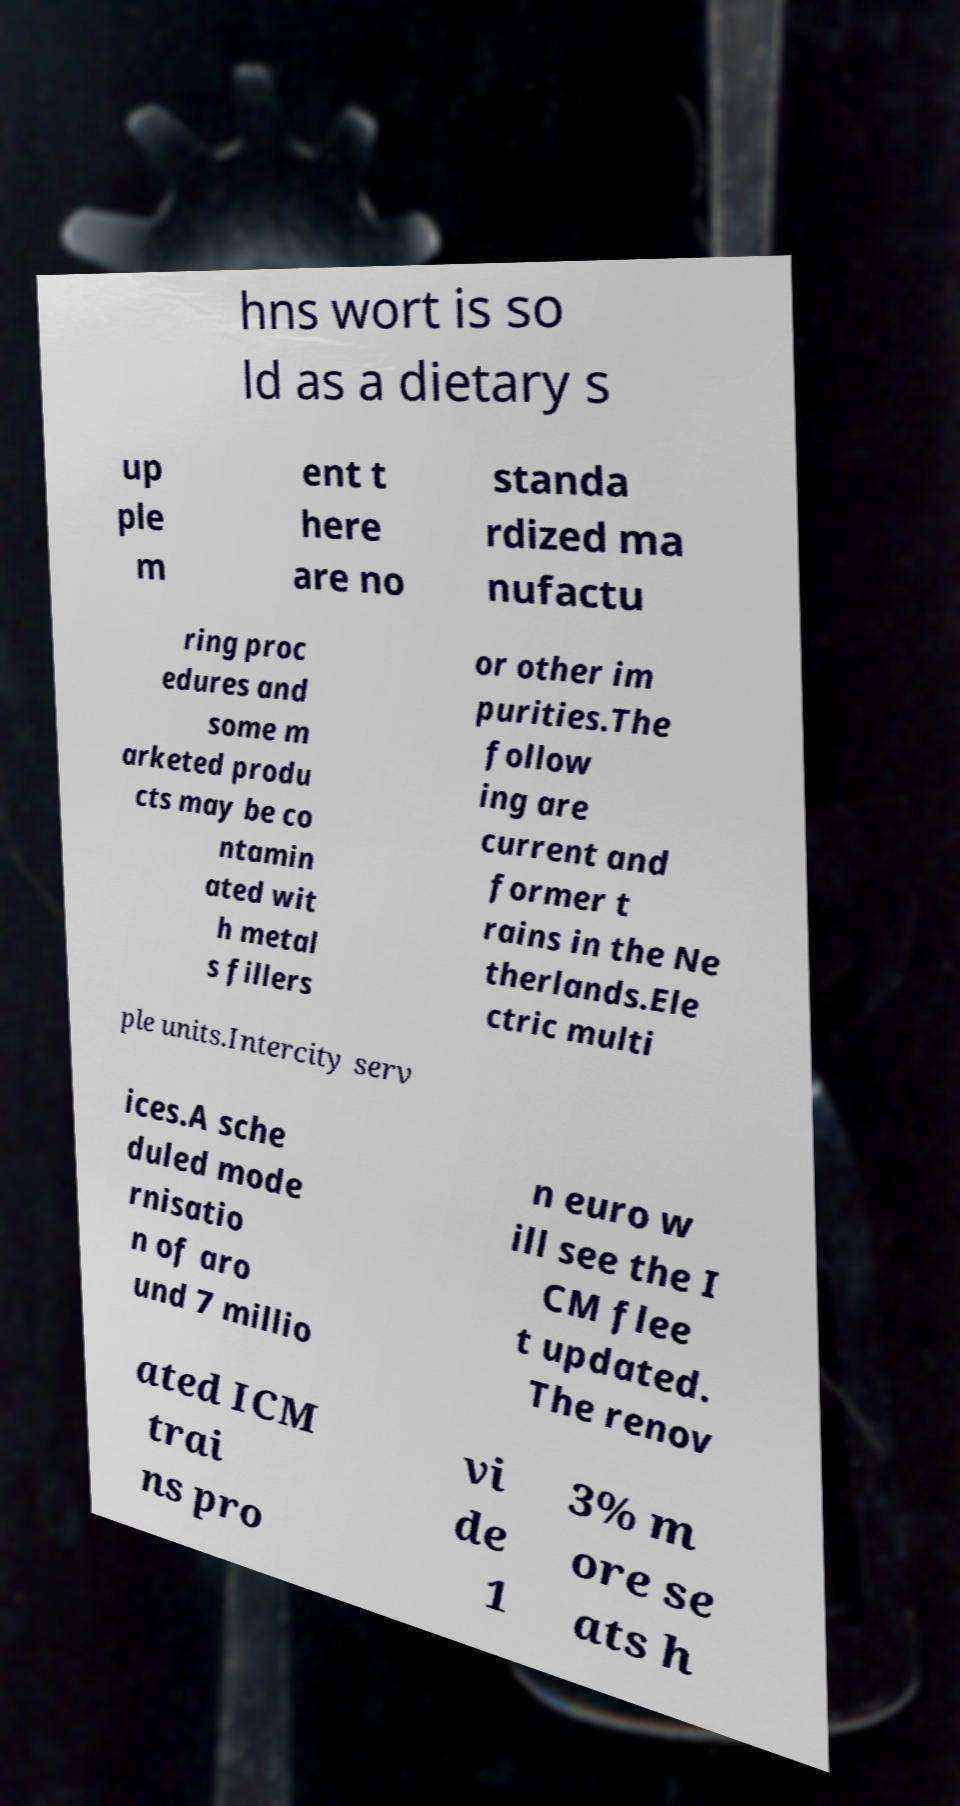There's text embedded in this image that I need extracted. Can you transcribe it verbatim? hns wort is so ld as a dietary s up ple m ent t here are no standa rdized ma nufactu ring proc edures and some m arketed produ cts may be co ntamin ated wit h metal s fillers or other im purities.The follow ing are current and former t rains in the Ne therlands.Ele ctric multi ple units.Intercity serv ices.A sche duled mode rnisatio n of aro und 7 millio n euro w ill see the I CM flee t updated. The renov ated ICM trai ns pro vi de 1 3% m ore se ats h 